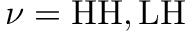<formula> <loc_0><loc_0><loc_500><loc_500>\nu = H H , L H</formula> 